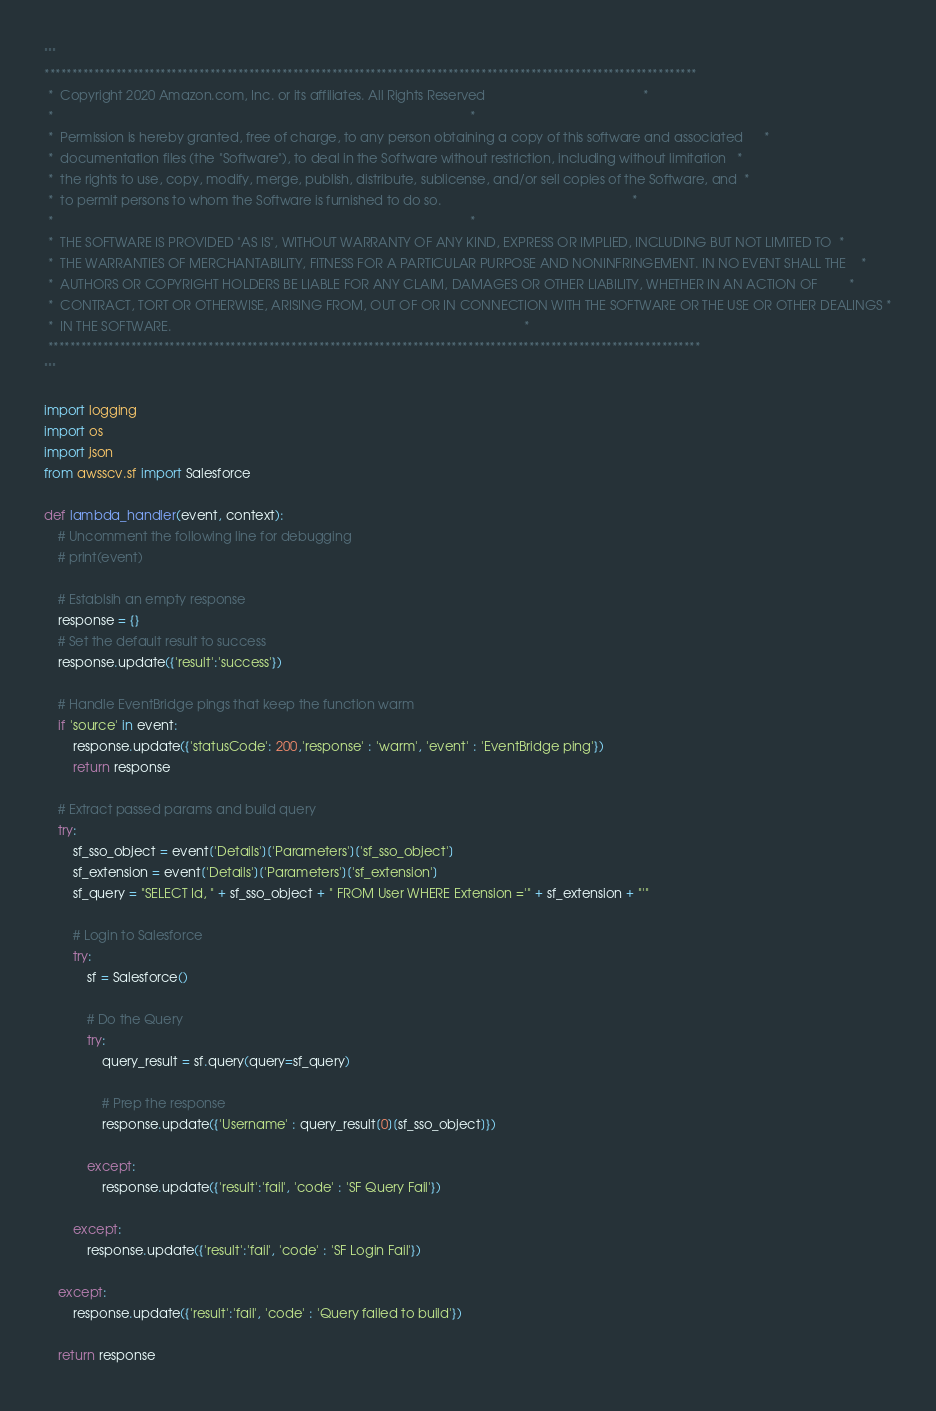<code> <loc_0><loc_0><loc_500><loc_500><_Python_>"""
**********************************************************************************************************************
 *  Copyright 2020 Amazon.com, Inc. or its affiliates. All Rights Reserved                                            *
 *                                                                                                                    *
 *  Permission is hereby granted, free of charge, to any person obtaining a copy of this software and associated      *
 *  documentation files (the "Software"), to deal in the Software without restriction, including without limitation   *
 *  the rights to use, copy, modify, merge, publish, distribute, sublicense, and/or sell copies of the Software, and  *
 *  to permit persons to whom the Software is furnished to do so.                                                     *
 *                                                                                                                    *
 *  THE SOFTWARE IS PROVIDED "AS IS", WITHOUT WARRANTY OF ANY KIND, EXPRESS OR IMPLIED, INCLUDING BUT NOT LIMITED TO  *
 *  THE WARRANTIES OF MERCHANTABILITY, FITNESS FOR A PARTICULAR PURPOSE AND NONINFRINGEMENT. IN NO EVENT SHALL THE    *
 *  AUTHORS OR COPYRIGHT HOLDERS BE LIABLE FOR ANY CLAIM, DAMAGES OR OTHER LIABILITY, WHETHER IN AN ACTION OF         *
 *  CONTRACT, TORT OR OTHERWISE, ARISING FROM, OUT OF OR IN CONNECTION WITH THE SOFTWARE OR THE USE OR OTHER DEALINGS *
 *  IN THE SOFTWARE.                                                                                                  *
 **********************************************************************************************************************
"""

import logging
import os
import json
from awsscv.sf import Salesforce

def lambda_handler(event, context):
    # Uncomment the following line for debugging
    # print(event)

    # Establsih an empty response
    response = {}
    # Set the default result to success
    response.update({'result':'success'})

    # Handle EventBridge pings that keep the function warm
    if 'source' in event:
        response.update({'statusCode': 200,'response' : 'warm', 'event' : 'EventBridge ping'})
        return response

    # Extract passed params and build query
    try:
        sf_sso_object = event['Details']['Parameters']['sf_sso_object']
        sf_extension = event['Details']['Parameters']['sf_extension']
        sf_query = "SELECT Id, " + sf_sso_object + " FROM User WHERE Extension ='" + sf_extension + "'"

        # Login to Salesforce
        try:
            sf = Salesforce()

            # Do the Query
            try:
                query_result = sf.query(query=sf_query)

                # Prep the response
                response.update({'Username' : query_result[0][sf_sso_object]})

            except:
                response.update({'result':'fail', 'code' : 'SF Query Fail'})

        except:
            response.update({'result':'fail', 'code' : 'SF Login Fail'})

    except:
        response.update({'result':'fail', 'code' : 'Query failed to build'})

    return response
</code> 